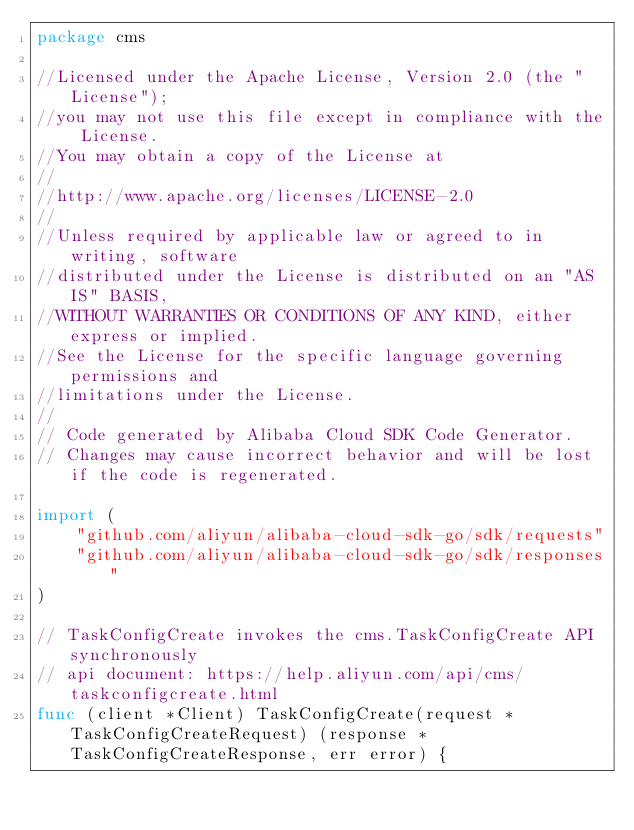Convert code to text. <code><loc_0><loc_0><loc_500><loc_500><_Go_>package cms

//Licensed under the Apache License, Version 2.0 (the "License");
//you may not use this file except in compliance with the License.
//You may obtain a copy of the License at
//
//http://www.apache.org/licenses/LICENSE-2.0
//
//Unless required by applicable law or agreed to in writing, software
//distributed under the License is distributed on an "AS IS" BASIS,
//WITHOUT WARRANTIES OR CONDITIONS OF ANY KIND, either express or implied.
//See the License for the specific language governing permissions and
//limitations under the License.
//
// Code generated by Alibaba Cloud SDK Code Generator.
// Changes may cause incorrect behavior and will be lost if the code is regenerated.

import (
	"github.com/aliyun/alibaba-cloud-sdk-go/sdk/requests"
	"github.com/aliyun/alibaba-cloud-sdk-go/sdk/responses"
)

// TaskConfigCreate invokes the cms.TaskConfigCreate API synchronously
// api document: https://help.aliyun.com/api/cms/taskconfigcreate.html
func (client *Client) TaskConfigCreate(request *TaskConfigCreateRequest) (response *TaskConfigCreateResponse, err error) {</code> 